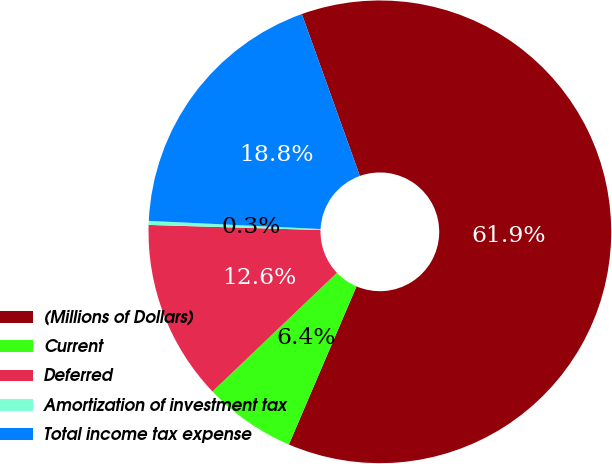Convert chart to OTSL. <chart><loc_0><loc_0><loc_500><loc_500><pie_chart><fcel>(Millions of Dollars)<fcel>Current<fcel>Deferred<fcel>Amortization of investment tax<fcel>Total income tax expense<nl><fcel>61.91%<fcel>6.44%<fcel>12.6%<fcel>0.28%<fcel>18.77%<nl></chart> 